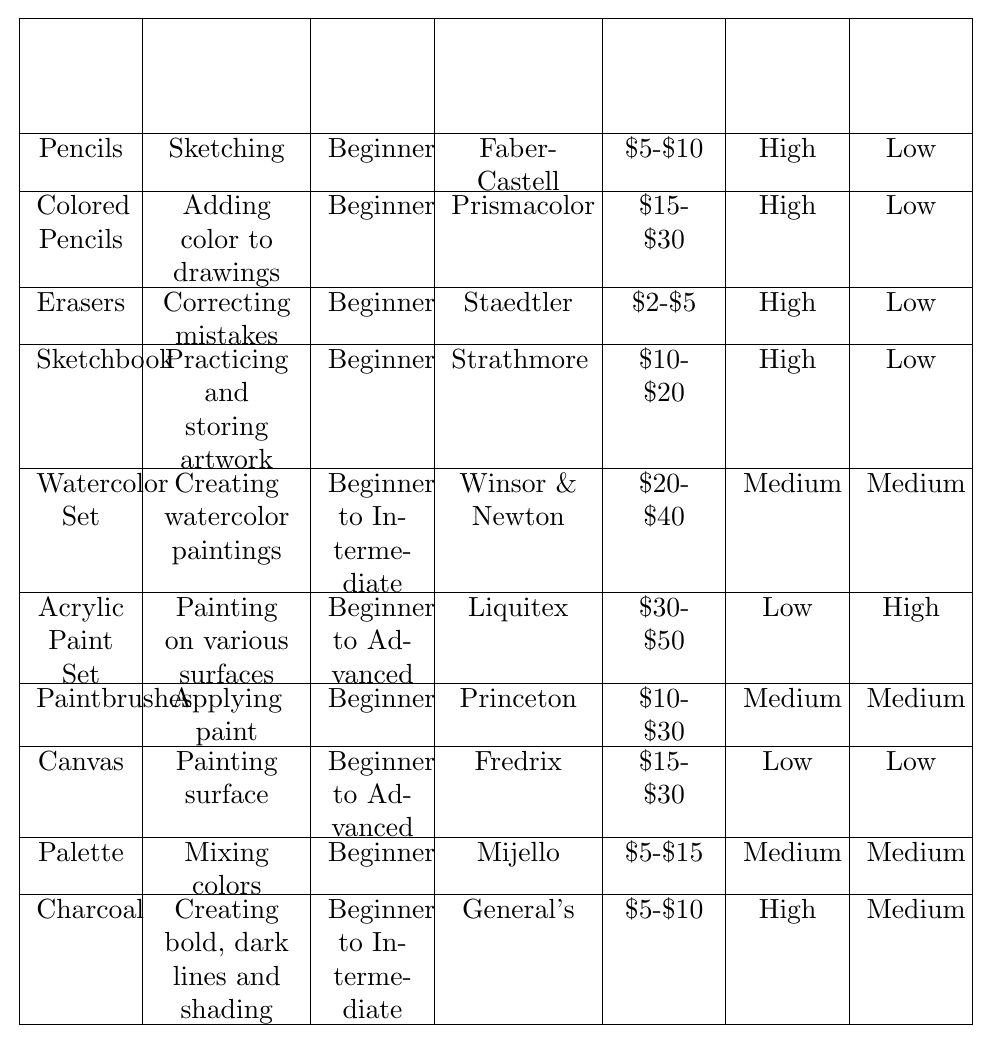What is the primary use of Charcoal? By looking at the row for Charcoal in the table, we see that it is used for creating bold, dark lines and shading.
Answer: Creating bold, dark lines and shading How much does an Eraser typically cost? The Estimated Cost column shows that an Eraser costs between $2 and $5.
Answer: $2-$5 Which art supplies are suitable for beginners? By examining the Skill Level column, we can see that Pencils, Colored Pencils, Erasers, Sketchbook, Paintbrushes, Palette, and Charcoal are all marked as Beginner.
Answer: Pencils, Colored Pencils, Erasers, Sketchbook, Paintbrushes, Palette, Charcoal What is the recommended brand for the Acrylic Paint Set? The Recommended Brand column for the Acrylic Paint Set lists Liquitex as the brand.
Answer: Liquitex Which art supplies require high cleanup? Checking the Cleanup Required column, we find that the Acrylic Paint Set requires high cleanup.
Answer: Acrylic Paint Set What is the portability level of a Watercolor Set? The table shows that the Watercolor Set has a medium portability rating.
Answer: Medium Can you find any supplies that have both low cleanup and high portability? By reviewing the Portability and Cleanup Required columns, we see that Pencils, Colored Pencils, Erasers, Sketchbook, and Canvas have low cleanup and Pencils, Colored Pencils, Erasers, Sketchbook, and Charcoal have high portability.
Answer: Pencils, Colored Pencils, Erasers, Sketchbook Is the primary use of a Palette the same as that of an Eraser? The primary use of a Palette is mixing colors, while that of an Eraser is correcting mistakes. Since they are different, the answer is no.
Answer: No How many art supplies are suitable for intermediate users? Reviewing the Skill Level column, we see that there are four supplies (Watercolor Set, Acrylic Paint Set, Charcoal) categorized as Beginner to Intermediate or Advanced. Adding them up shows that there are three suitable for intermediate users.
Answer: Three Which art supplies have a cost of over $25? The supplies that are priced $20 or higher based on the Estimated Cost column are Watercolor Set, Acrylic Paint Set, and Canvas. This shows three supplies that fit the criteria.
Answer: Watercolor Set, Acrylic Paint Set, Canvas 